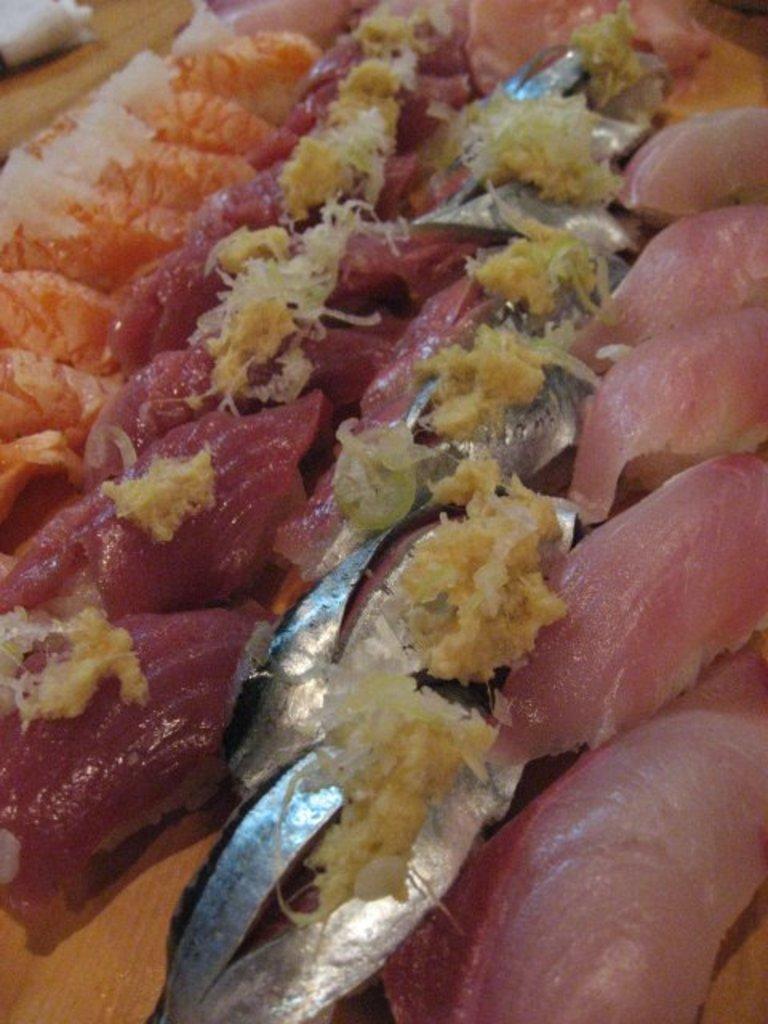How would you summarize this image in a sentence or two? This image consist of food. 